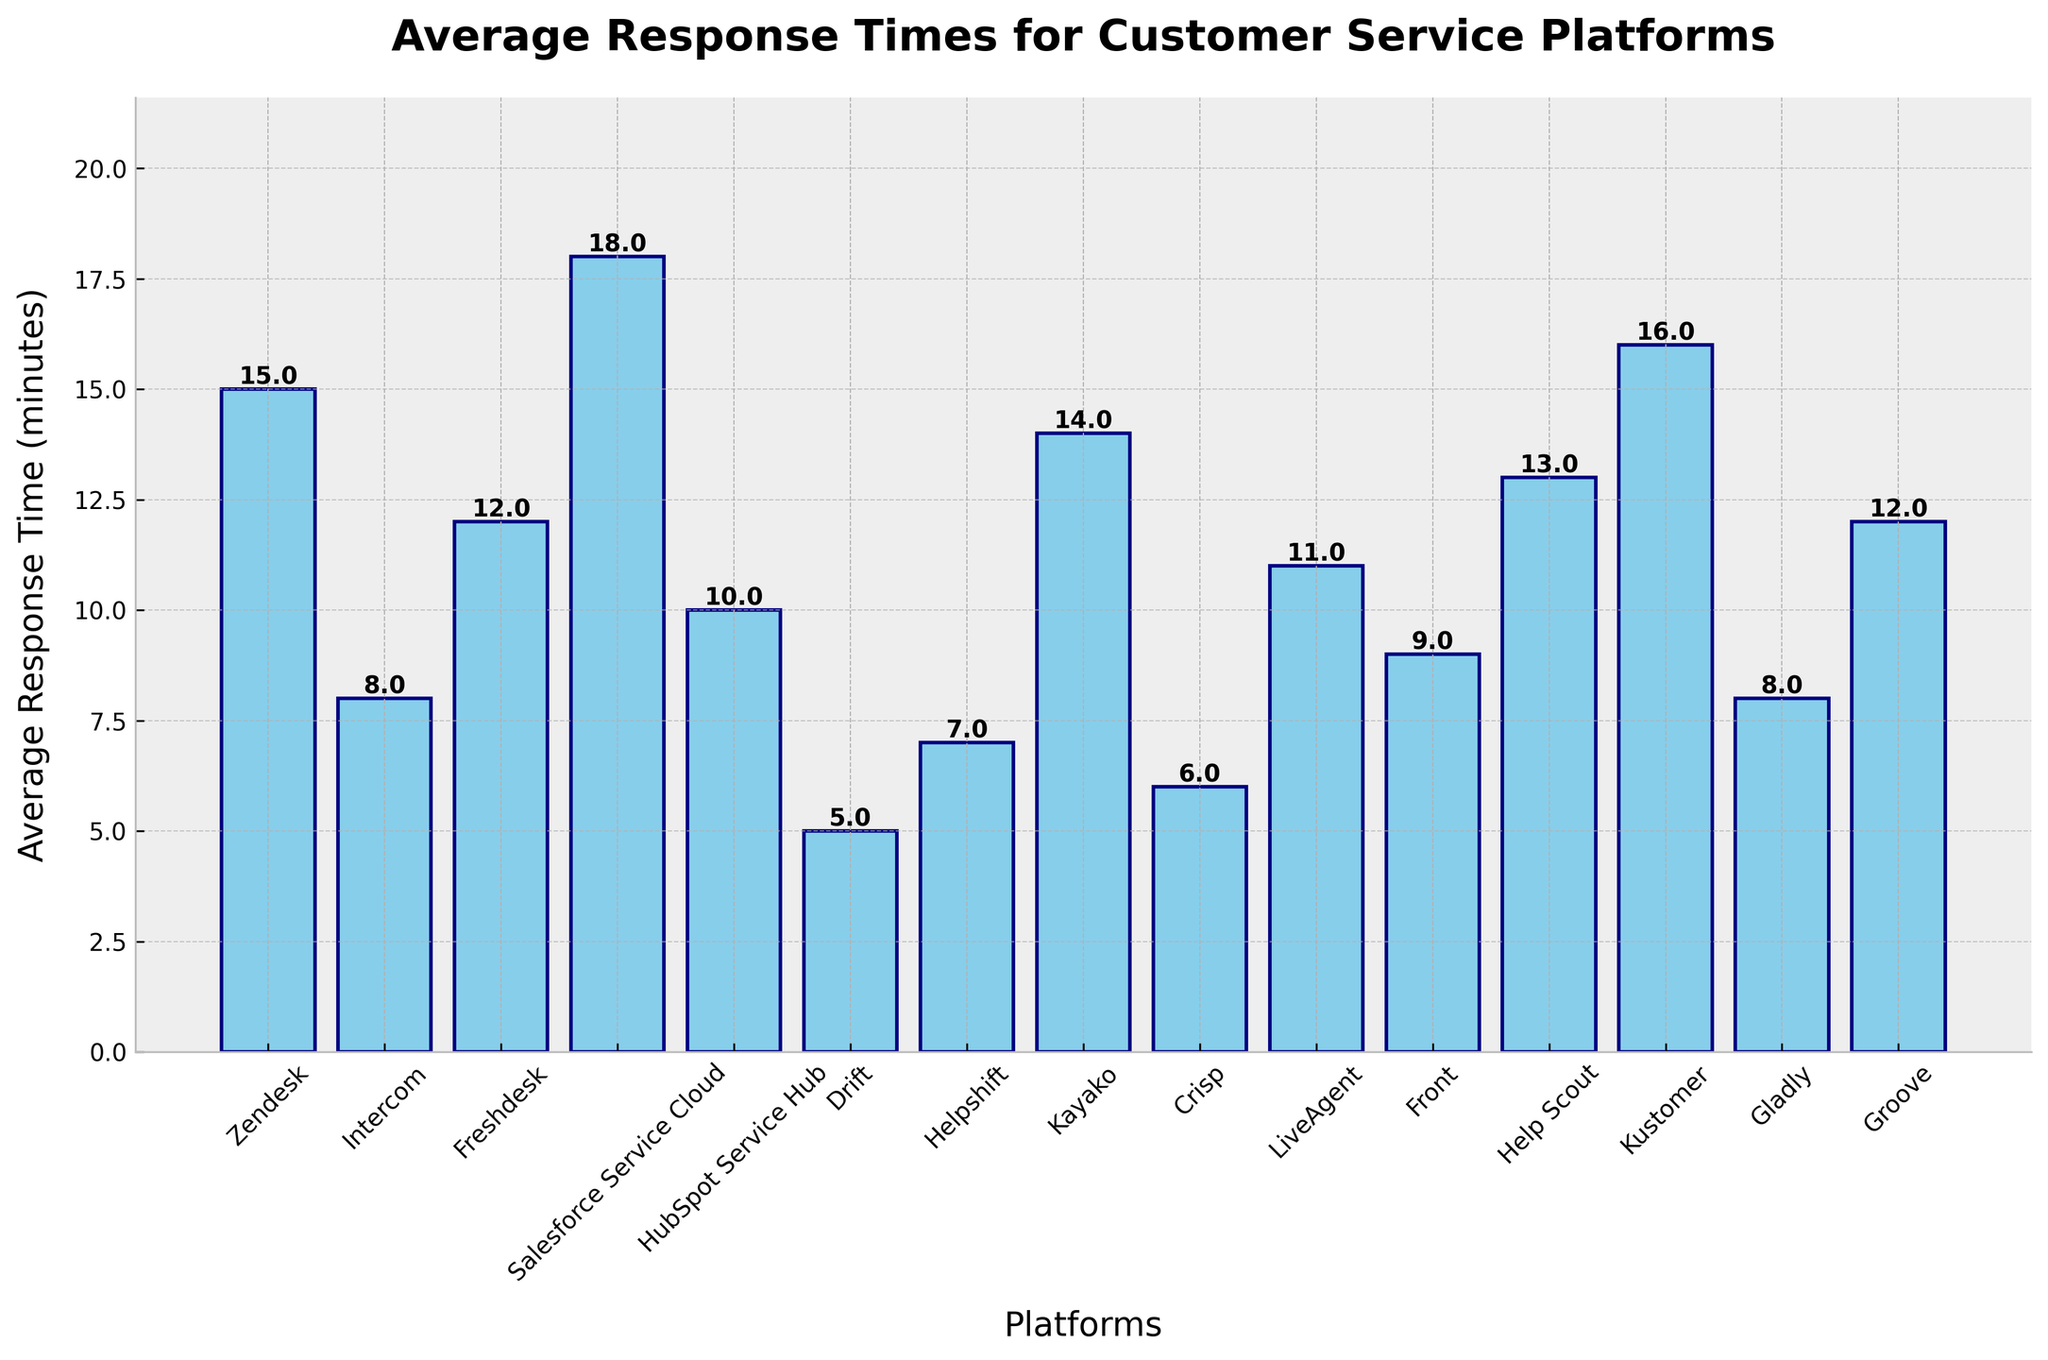What is the average response time for Drift? Identify the bar labeled "Drift", then look at the height of the bar and/or the text label above it, which shows the average response time of 5 minutes.
Answer: 5 minutes Which platform has the highest average response time? Compare the height of all bars; the tallest one represents the platform with the highest average response time. "Salesforce Service Cloud" has the tallest bar at 18 minutes.
Answer: Salesforce Service Cloud How many platforms have an average response time of less than 10 minutes? Count the bars with heights less than 10 minutes: Intercom, Drift, Helpshift, Crisp, and Gladly.
Answer: 5 platforms What is the difference between the average response times of HubSpot Service Hub and Front? Subtract the average response time of Front (9 minutes) from HubSpot Service Hub (10 minutes).
Answer: 1 minute Which platform has a lower average response time, Helpshift or Kayako? Compare the heights or text labels of the bars for Helpshift (7 minutes) and Kayako (14 minutes).
Answer: Helpshift What is the sum of the average response times for Zendesk, Intercom, and Freshdesk? Add the average response times for Zendesk (15 minutes), Intercom (8 minutes), and Freshdesk (12 minutes).
Answer: 35 minutes Is the average response time for Crisp greater than that for Drift? Compare the heights or text labels of the bars for Crisp (6 minutes) and Drift (5 minutes).
Answer: No What is the median average response time for all the platforms? Arrange the response times in ascending order and find the middle value(s). The sorted times are: 5, 6, 7, 8, 8, 9, 10, 11, 12, 12, 13, 14, 15, 16, 18. The middle value is 11.
Answer: 11 minutes How many platforms have an average response time greater than or equal to 15 minutes? Count the bars that have heights greater than or equal to 15 minutes: Zendesk, Salesforce Service Cloud, Kustomer.
Answer: 3 platforms 